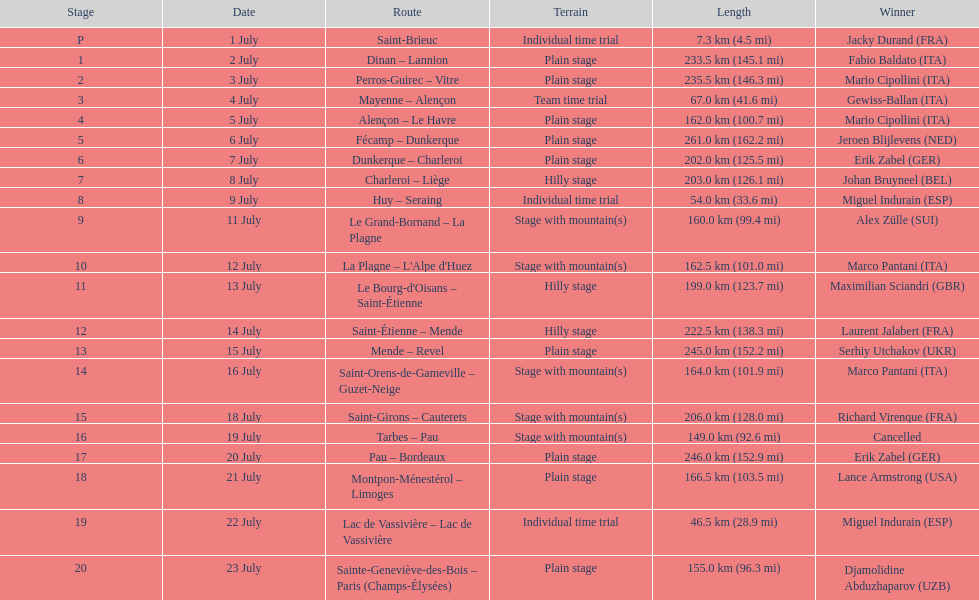How many routes have below 100 km total? 4. Could you help me parse every detail presented in this table? {'header': ['Stage', 'Date', 'Route', 'Terrain', 'Length', 'Winner'], 'rows': [['P', '1 July', 'Saint-Brieuc', 'Individual time trial', '7.3\xa0km (4.5\xa0mi)', 'Jacky Durand\xa0(FRA)'], ['1', '2 July', 'Dinan – Lannion', 'Plain stage', '233.5\xa0km (145.1\xa0mi)', 'Fabio Baldato\xa0(ITA)'], ['2', '3 July', 'Perros-Guirec – Vitre', 'Plain stage', '235.5\xa0km (146.3\xa0mi)', 'Mario Cipollini\xa0(ITA)'], ['3', '4 July', 'Mayenne – Alençon', 'Team time trial', '67.0\xa0km (41.6\xa0mi)', 'Gewiss-Ballan\xa0(ITA)'], ['4', '5 July', 'Alençon – Le Havre', 'Plain stage', '162.0\xa0km (100.7\xa0mi)', 'Mario Cipollini\xa0(ITA)'], ['5', '6 July', 'Fécamp – Dunkerque', 'Plain stage', '261.0\xa0km (162.2\xa0mi)', 'Jeroen Blijlevens\xa0(NED)'], ['6', '7 July', 'Dunkerque – Charleroi', 'Plain stage', '202.0\xa0km (125.5\xa0mi)', 'Erik Zabel\xa0(GER)'], ['7', '8 July', 'Charleroi – Liège', 'Hilly stage', '203.0\xa0km (126.1\xa0mi)', 'Johan Bruyneel\xa0(BEL)'], ['8', '9 July', 'Huy – Seraing', 'Individual time trial', '54.0\xa0km (33.6\xa0mi)', 'Miguel Indurain\xa0(ESP)'], ['9', '11 July', 'Le Grand-Bornand – La Plagne', 'Stage with mountain(s)', '160.0\xa0km (99.4\xa0mi)', 'Alex Zülle\xa0(SUI)'], ['10', '12 July', "La Plagne – L'Alpe d'Huez", 'Stage with mountain(s)', '162.5\xa0km (101.0\xa0mi)', 'Marco Pantani\xa0(ITA)'], ['11', '13 July', "Le Bourg-d'Oisans – Saint-Étienne", 'Hilly stage', '199.0\xa0km (123.7\xa0mi)', 'Maximilian Sciandri\xa0(GBR)'], ['12', '14 July', 'Saint-Étienne – Mende', 'Hilly stage', '222.5\xa0km (138.3\xa0mi)', 'Laurent Jalabert\xa0(FRA)'], ['13', '15 July', 'Mende – Revel', 'Plain stage', '245.0\xa0km (152.2\xa0mi)', 'Serhiy Utchakov\xa0(UKR)'], ['14', '16 July', 'Saint-Orens-de-Gameville – Guzet-Neige', 'Stage with mountain(s)', '164.0\xa0km (101.9\xa0mi)', 'Marco Pantani\xa0(ITA)'], ['15', '18 July', 'Saint-Girons – Cauterets', 'Stage with mountain(s)', '206.0\xa0km (128.0\xa0mi)', 'Richard Virenque\xa0(FRA)'], ['16', '19 July', 'Tarbes – Pau', 'Stage with mountain(s)', '149.0\xa0km (92.6\xa0mi)', 'Cancelled'], ['17', '20 July', 'Pau – Bordeaux', 'Plain stage', '246.0\xa0km (152.9\xa0mi)', 'Erik Zabel\xa0(GER)'], ['18', '21 July', 'Montpon-Ménestérol – Limoges', 'Plain stage', '166.5\xa0km (103.5\xa0mi)', 'Lance Armstrong\xa0(USA)'], ['19', '22 July', 'Lac de Vassivière – Lac de Vassivière', 'Individual time trial', '46.5\xa0km (28.9\xa0mi)', 'Miguel Indurain\xa0(ESP)'], ['20', '23 July', 'Sainte-Geneviève-des-Bois – Paris (Champs-Élysées)', 'Plain stage', '155.0\xa0km (96.3\xa0mi)', 'Djamolidine Abduzhaparov\xa0(UZB)']]} 